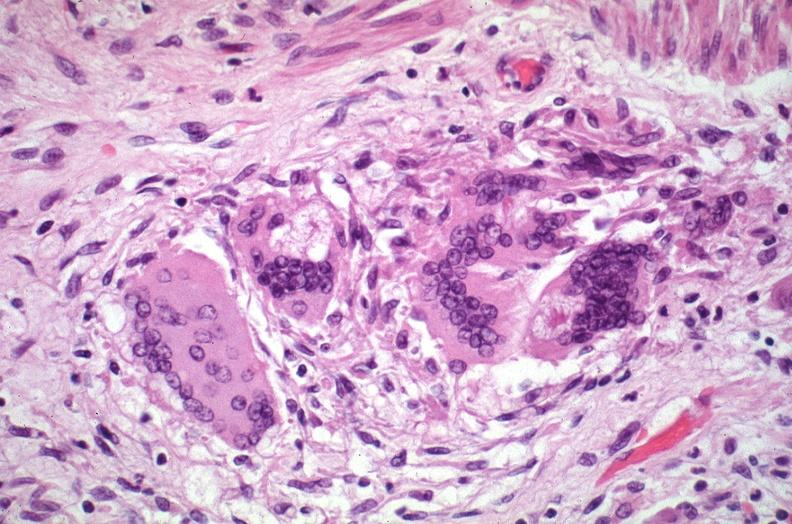how does this image show lung, sarcoidosis, multinucleated giant cells?
Answer the question using a single word or phrase. With asteroid bodies 